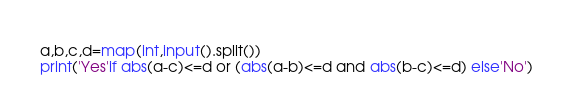<code> <loc_0><loc_0><loc_500><loc_500><_Python_>a,b,c,d=map(int,input().split())
print('Yes'if abs(a-c)<=d or (abs(a-b)<=d and abs(b-c)<=d) else'No')
</code> 